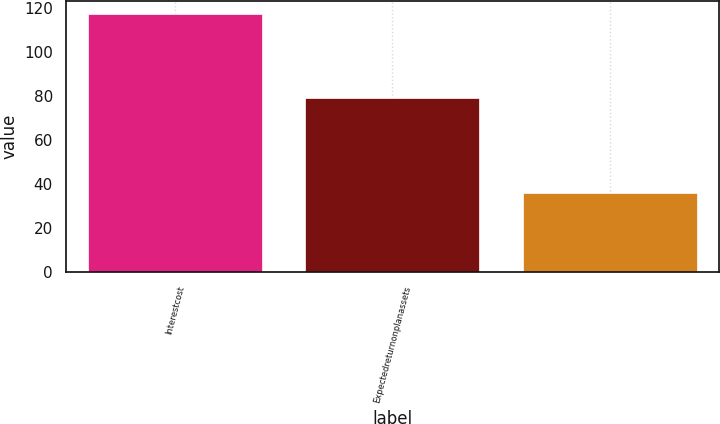Convert chart. <chart><loc_0><loc_0><loc_500><loc_500><bar_chart><fcel>Interestcost<fcel>Expectedreturnonplanassets<fcel>Unnamed: 2<nl><fcel>117<fcel>79<fcel>36<nl></chart> 